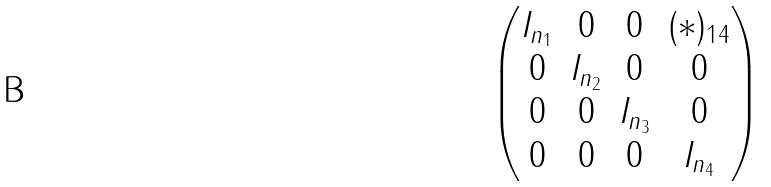<formula> <loc_0><loc_0><loc_500><loc_500>\begin{pmatrix} I _ { n _ { 1 } } & 0 & 0 & ( * ) _ { 1 4 } \\ 0 & I _ { n _ { 2 } } & 0 & 0 \\ 0 & 0 & I _ { n _ { 3 } } & 0 \\ 0 & 0 & 0 & I _ { n _ { 4 } } \\ \end{pmatrix}</formula> 